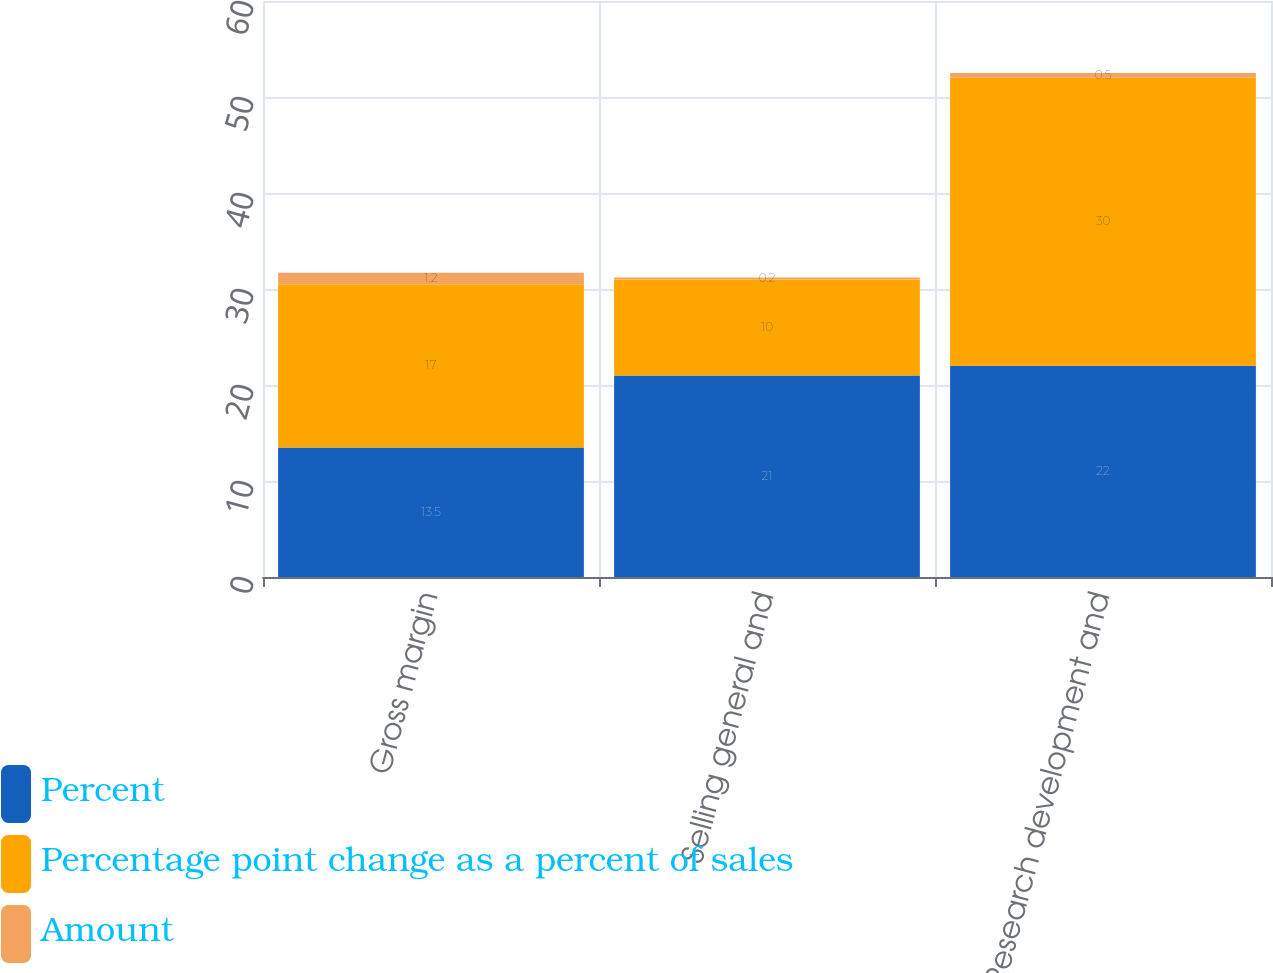Convert chart to OTSL. <chart><loc_0><loc_0><loc_500><loc_500><stacked_bar_chart><ecel><fcel>Gross margin<fcel>Selling general and<fcel>Research development and<nl><fcel>Percent<fcel>13.5<fcel>21<fcel>22<nl><fcel>Percentage point change as a percent of sales<fcel>17<fcel>10<fcel>30<nl><fcel>Amount<fcel>1.2<fcel>0.2<fcel>0.5<nl></chart> 